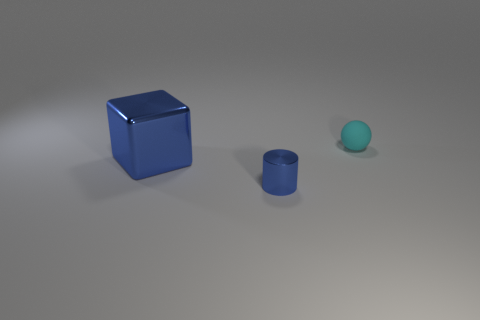Add 3 cyan things. How many objects exist? 6 Subtract all spheres. How many objects are left? 2 Add 2 large matte things. How many large matte things exist? 2 Subtract 0 brown spheres. How many objects are left? 3 Subtract all cubes. Subtract all tiny cyan rubber things. How many objects are left? 1 Add 1 cyan rubber things. How many cyan rubber things are left? 2 